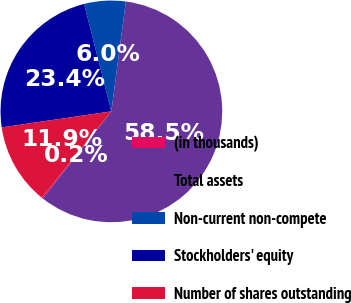Convert chart to OTSL. <chart><loc_0><loc_0><loc_500><loc_500><pie_chart><fcel>(in thousands)<fcel>Total assets<fcel>Non-current non-compete<fcel>Stockholders' equity<fcel>Number of shares outstanding<nl><fcel>0.21%<fcel>58.53%<fcel>6.04%<fcel>23.35%<fcel>11.87%<nl></chart> 